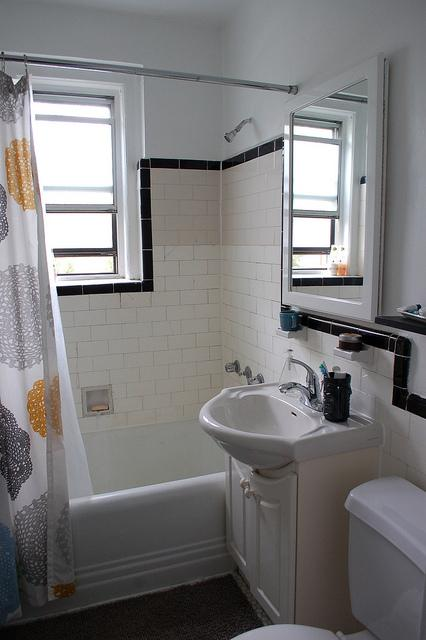What is one of the colors on the curtain? Please explain your reasoning. yellow. The curtain is gray and orange. 